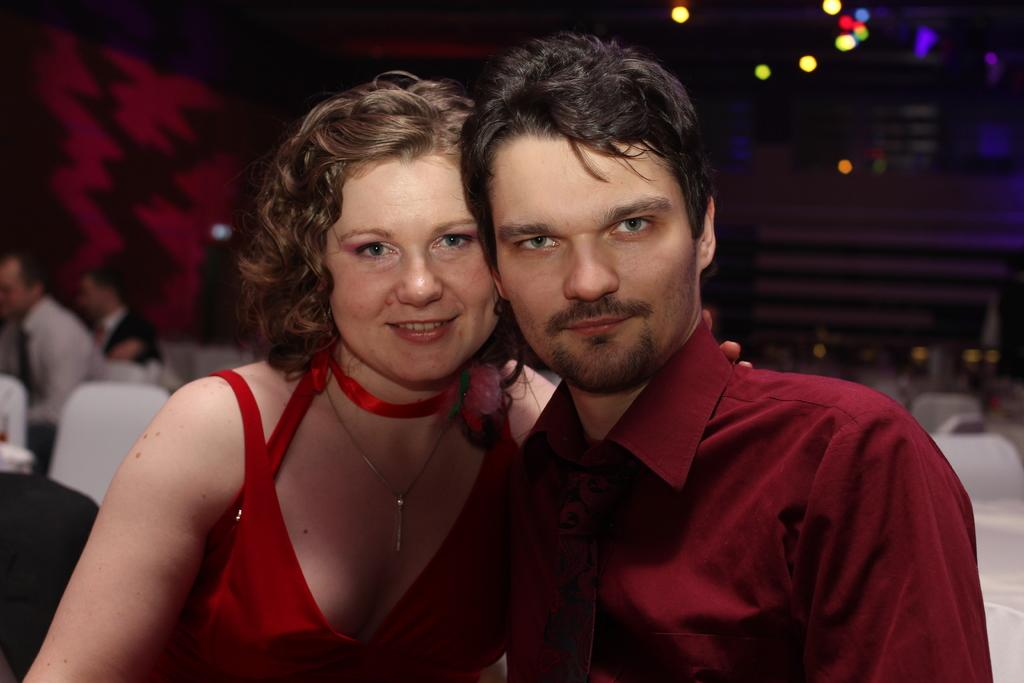How many people are in the image? There are two people in the image. What is the facial expression of the people in the image? The two people are smiling. What can be seen in the background of the image? There are people, chairs, lights, and some objects in the background of the image. What type of cakes are being used to create the fog in the image? There is no fog or cakes present in the image. How does the use of cakes contribute to the fog in the image? The image does not depict any fog or cakes, so it is not possible to determine how they might be related. 